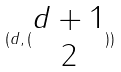<formula> <loc_0><loc_0><loc_500><loc_500>( d , ( \begin{matrix} d + 1 \\ 2 \end{matrix} ) )</formula> 